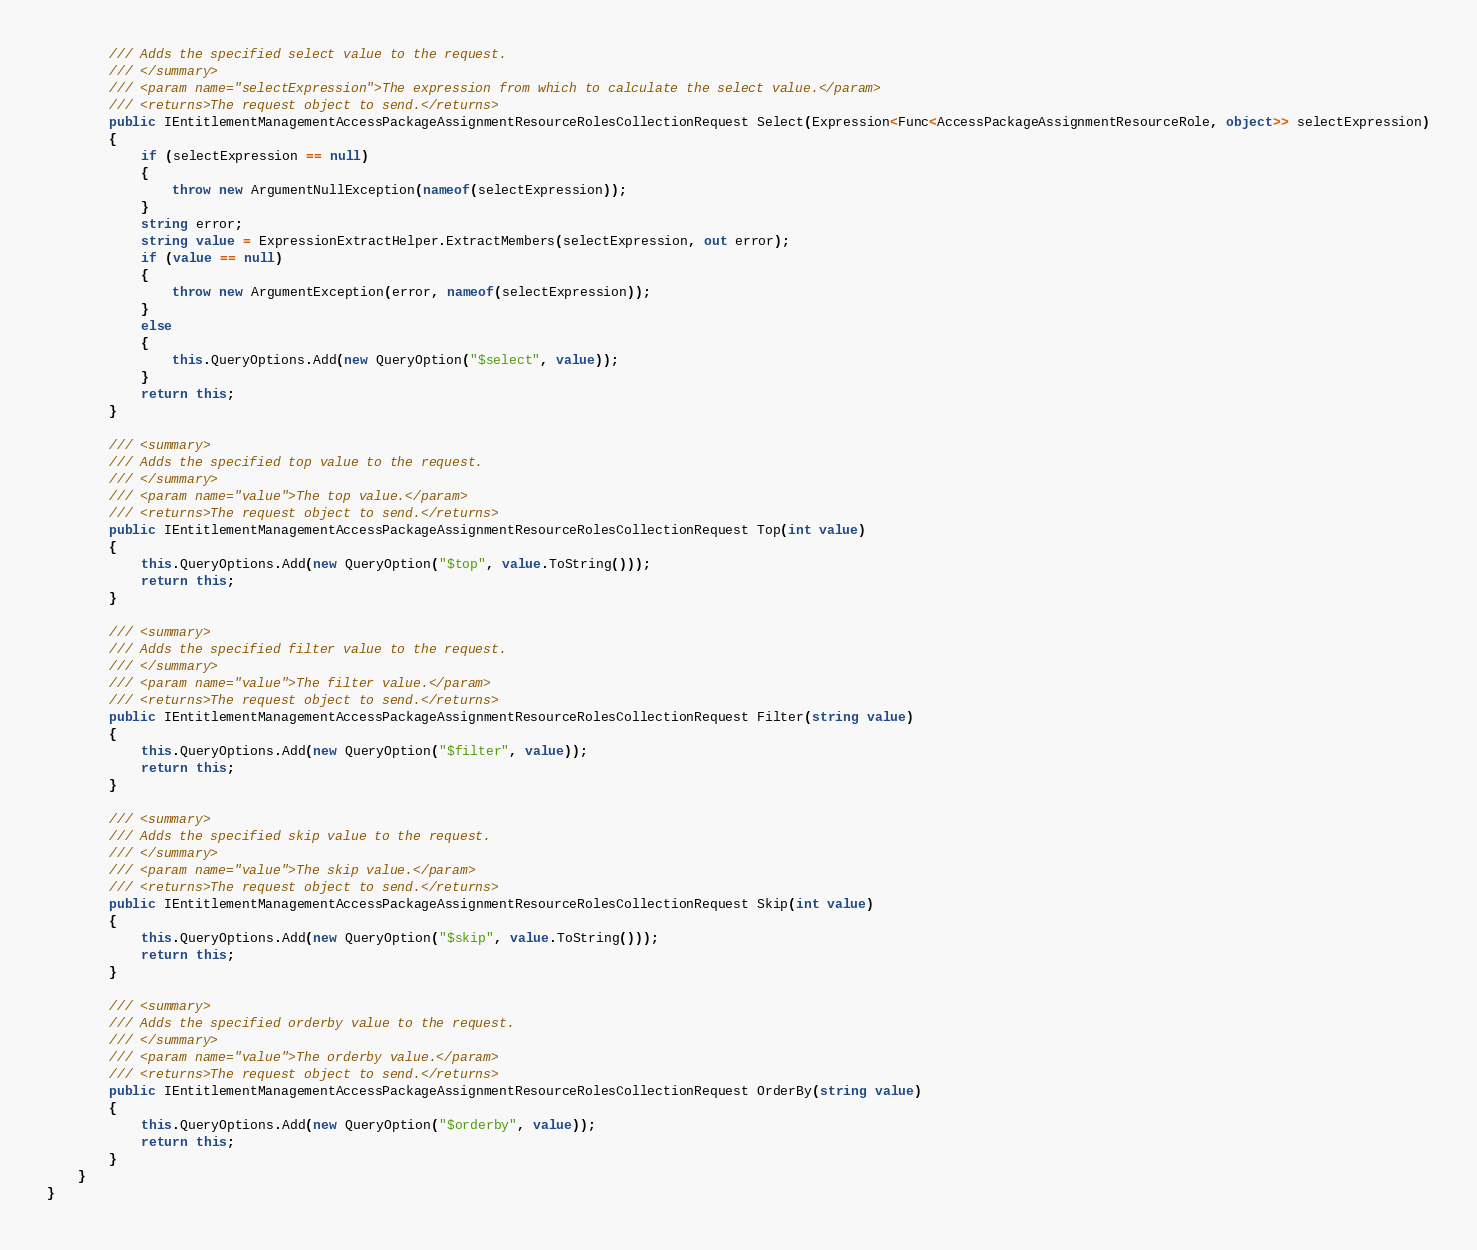Convert code to text. <code><loc_0><loc_0><loc_500><loc_500><_C#_>        /// Adds the specified select value to the request.
        /// </summary>
        /// <param name="selectExpression">The expression from which to calculate the select value.</param>
        /// <returns>The request object to send.</returns>
        public IEntitlementManagementAccessPackageAssignmentResourceRolesCollectionRequest Select(Expression<Func<AccessPackageAssignmentResourceRole, object>> selectExpression)
        {
            if (selectExpression == null)
            {
                throw new ArgumentNullException(nameof(selectExpression));
            }
            string error;
            string value = ExpressionExtractHelper.ExtractMembers(selectExpression, out error);
            if (value == null)
            {
                throw new ArgumentException(error, nameof(selectExpression));
            }
            else
            {
                this.QueryOptions.Add(new QueryOption("$select", value));
            }
            return this;
        }

        /// <summary>
        /// Adds the specified top value to the request.
        /// </summary>
        /// <param name="value">The top value.</param>
        /// <returns>The request object to send.</returns>
        public IEntitlementManagementAccessPackageAssignmentResourceRolesCollectionRequest Top(int value)
        {
            this.QueryOptions.Add(new QueryOption("$top", value.ToString()));
            return this;
        }

        /// <summary>
        /// Adds the specified filter value to the request.
        /// </summary>
        /// <param name="value">The filter value.</param>
        /// <returns>The request object to send.</returns>
        public IEntitlementManagementAccessPackageAssignmentResourceRolesCollectionRequest Filter(string value)
        {
            this.QueryOptions.Add(new QueryOption("$filter", value));
            return this;
        }

        /// <summary>
        /// Adds the specified skip value to the request.
        /// </summary>
        /// <param name="value">The skip value.</param>
        /// <returns>The request object to send.</returns>
        public IEntitlementManagementAccessPackageAssignmentResourceRolesCollectionRequest Skip(int value)
        {
            this.QueryOptions.Add(new QueryOption("$skip", value.ToString()));
            return this;
        }

        /// <summary>
        /// Adds the specified orderby value to the request.
        /// </summary>
        /// <param name="value">The orderby value.</param>
        /// <returns>The request object to send.</returns>
        public IEntitlementManagementAccessPackageAssignmentResourceRolesCollectionRequest OrderBy(string value)
        {
            this.QueryOptions.Add(new QueryOption("$orderby", value));
            return this;
        }
    }
}
</code> 